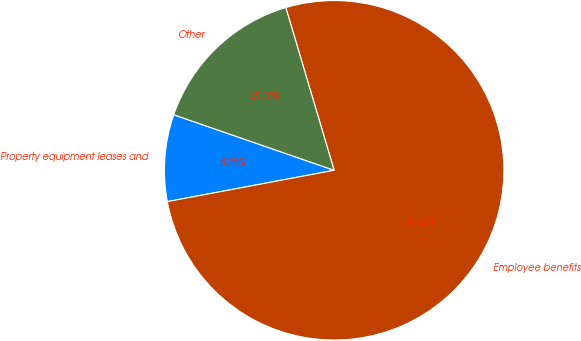<chart> <loc_0><loc_0><loc_500><loc_500><pie_chart><fcel>Property equipment leases and<fcel>Employee benefits<fcel>Other<nl><fcel>8.26%<fcel>76.64%<fcel>15.1%<nl></chart> 